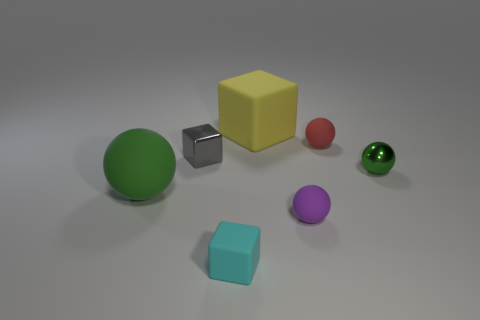Subtract all small red rubber balls. How many balls are left? 3 Subtract all gray balls. Subtract all yellow cubes. How many balls are left? 4 Add 2 tiny objects. How many objects exist? 9 Subtract all cubes. How many objects are left? 4 Add 5 small purple spheres. How many small purple spheres are left? 6 Add 6 shiny spheres. How many shiny spheres exist? 7 Subtract 1 yellow blocks. How many objects are left? 6 Subtract all cyan matte blocks. Subtract all tiny gray objects. How many objects are left? 5 